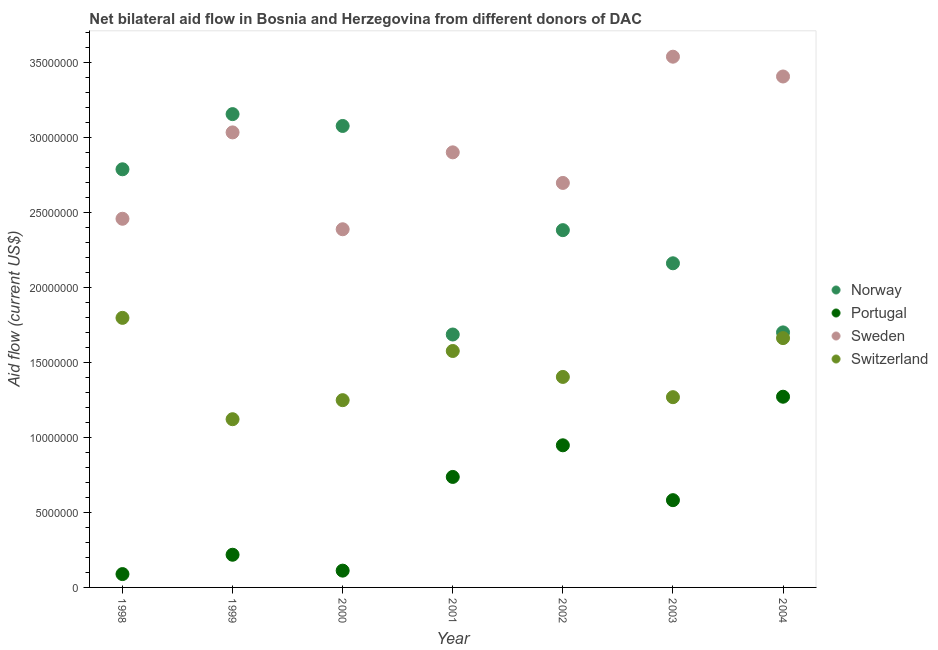How many different coloured dotlines are there?
Make the answer very short. 4. Is the number of dotlines equal to the number of legend labels?
Your response must be concise. Yes. What is the amount of aid given by sweden in 2001?
Offer a terse response. 2.90e+07. Across all years, what is the maximum amount of aid given by switzerland?
Your answer should be very brief. 1.80e+07. Across all years, what is the minimum amount of aid given by sweden?
Offer a very short reply. 2.39e+07. In which year was the amount of aid given by sweden maximum?
Offer a terse response. 2003. What is the total amount of aid given by switzerland in the graph?
Your response must be concise. 1.01e+08. What is the difference between the amount of aid given by portugal in 1999 and that in 2004?
Give a very brief answer. -1.05e+07. What is the difference between the amount of aid given by sweden in 2001 and the amount of aid given by switzerland in 2000?
Offer a terse response. 1.65e+07. What is the average amount of aid given by switzerland per year?
Your response must be concise. 1.44e+07. In the year 2001, what is the difference between the amount of aid given by portugal and amount of aid given by sweden?
Your answer should be very brief. -2.16e+07. In how many years, is the amount of aid given by sweden greater than 28000000 US$?
Offer a very short reply. 4. What is the ratio of the amount of aid given by portugal in 2001 to that in 2003?
Ensure brevity in your answer.  1.27. What is the difference between the highest and the second highest amount of aid given by switzerland?
Offer a very short reply. 1.35e+06. What is the difference between the highest and the lowest amount of aid given by portugal?
Provide a succinct answer. 1.18e+07. Is the sum of the amount of aid given by switzerland in 2002 and 2004 greater than the maximum amount of aid given by portugal across all years?
Ensure brevity in your answer.  Yes. Is the amount of aid given by sweden strictly less than the amount of aid given by norway over the years?
Offer a very short reply. No. Are the values on the major ticks of Y-axis written in scientific E-notation?
Provide a succinct answer. No. Does the graph contain grids?
Make the answer very short. No. What is the title of the graph?
Provide a short and direct response. Net bilateral aid flow in Bosnia and Herzegovina from different donors of DAC. What is the label or title of the X-axis?
Ensure brevity in your answer.  Year. What is the Aid flow (current US$) in Norway in 1998?
Offer a terse response. 2.79e+07. What is the Aid flow (current US$) of Portugal in 1998?
Offer a terse response. 8.90e+05. What is the Aid flow (current US$) of Sweden in 1998?
Offer a very short reply. 2.46e+07. What is the Aid flow (current US$) in Switzerland in 1998?
Your response must be concise. 1.80e+07. What is the Aid flow (current US$) in Norway in 1999?
Keep it short and to the point. 3.16e+07. What is the Aid flow (current US$) in Portugal in 1999?
Give a very brief answer. 2.18e+06. What is the Aid flow (current US$) of Sweden in 1999?
Offer a terse response. 3.04e+07. What is the Aid flow (current US$) of Switzerland in 1999?
Your answer should be very brief. 1.12e+07. What is the Aid flow (current US$) in Norway in 2000?
Ensure brevity in your answer.  3.08e+07. What is the Aid flow (current US$) of Portugal in 2000?
Keep it short and to the point. 1.12e+06. What is the Aid flow (current US$) of Sweden in 2000?
Provide a short and direct response. 2.39e+07. What is the Aid flow (current US$) in Switzerland in 2000?
Your response must be concise. 1.25e+07. What is the Aid flow (current US$) of Norway in 2001?
Make the answer very short. 1.69e+07. What is the Aid flow (current US$) of Portugal in 2001?
Provide a succinct answer. 7.37e+06. What is the Aid flow (current US$) of Sweden in 2001?
Give a very brief answer. 2.90e+07. What is the Aid flow (current US$) in Switzerland in 2001?
Your response must be concise. 1.58e+07. What is the Aid flow (current US$) in Norway in 2002?
Provide a short and direct response. 2.38e+07. What is the Aid flow (current US$) of Portugal in 2002?
Give a very brief answer. 9.48e+06. What is the Aid flow (current US$) in Sweden in 2002?
Offer a very short reply. 2.70e+07. What is the Aid flow (current US$) in Switzerland in 2002?
Keep it short and to the point. 1.40e+07. What is the Aid flow (current US$) of Norway in 2003?
Offer a very short reply. 2.16e+07. What is the Aid flow (current US$) in Portugal in 2003?
Your answer should be very brief. 5.82e+06. What is the Aid flow (current US$) in Sweden in 2003?
Offer a very short reply. 3.54e+07. What is the Aid flow (current US$) in Switzerland in 2003?
Offer a terse response. 1.27e+07. What is the Aid flow (current US$) in Norway in 2004?
Your answer should be compact. 1.70e+07. What is the Aid flow (current US$) of Portugal in 2004?
Your response must be concise. 1.27e+07. What is the Aid flow (current US$) in Sweden in 2004?
Your response must be concise. 3.41e+07. What is the Aid flow (current US$) of Switzerland in 2004?
Your response must be concise. 1.66e+07. Across all years, what is the maximum Aid flow (current US$) in Norway?
Provide a short and direct response. 3.16e+07. Across all years, what is the maximum Aid flow (current US$) in Portugal?
Your answer should be compact. 1.27e+07. Across all years, what is the maximum Aid flow (current US$) of Sweden?
Provide a short and direct response. 3.54e+07. Across all years, what is the maximum Aid flow (current US$) of Switzerland?
Give a very brief answer. 1.80e+07. Across all years, what is the minimum Aid flow (current US$) in Norway?
Your answer should be compact. 1.69e+07. Across all years, what is the minimum Aid flow (current US$) in Portugal?
Give a very brief answer. 8.90e+05. Across all years, what is the minimum Aid flow (current US$) in Sweden?
Keep it short and to the point. 2.39e+07. Across all years, what is the minimum Aid flow (current US$) in Switzerland?
Provide a succinct answer. 1.12e+07. What is the total Aid flow (current US$) in Norway in the graph?
Offer a terse response. 1.70e+08. What is the total Aid flow (current US$) in Portugal in the graph?
Make the answer very short. 3.96e+07. What is the total Aid flow (current US$) in Sweden in the graph?
Ensure brevity in your answer.  2.04e+08. What is the total Aid flow (current US$) of Switzerland in the graph?
Offer a terse response. 1.01e+08. What is the difference between the Aid flow (current US$) of Norway in 1998 and that in 1999?
Your response must be concise. -3.68e+06. What is the difference between the Aid flow (current US$) of Portugal in 1998 and that in 1999?
Keep it short and to the point. -1.29e+06. What is the difference between the Aid flow (current US$) of Sweden in 1998 and that in 1999?
Make the answer very short. -5.76e+06. What is the difference between the Aid flow (current US$) of Switzerland in 1998 and that in 1999?
Keep it short and to the point. 6.76e+06. What is the difference between the Aid flow (current US$) of Norway in 1998 and that in 2000?
Ensure brevity in your answer.  -2.89e+06. What is the difference between the Aid flow (current US$) in Sweden in 1998 and that in 2000?
Provide a succinct answer. 7.00e+05. What is the difference between the Aid flow (current US$) in Switzerland in 1998 and that in 2000?
Offer a terse response. 5.49e+06. What is the difference between the Aid flow (current US$) in Norway in 1998 and that in 2001?
Offer a terse response. 1.10e+07. What is the difference between the Aid flow (current US$) in Portugal in 1998 and that in 2001?
Your answer should be compact. -6.48e+06. What is the difference between the Aid flow (current US$) of Sweden in 1998 and that in 2001?
Provide a succinct answer. -4.43e+06. What is the difference between the Aid flow (current US$) in Switzerland in 1998 and that in 2001?
Give a very brief answer. 2.21e+06. What is the difference between the Aid flow (current US$) of Norway in 1998 and that in 2002?
Provide a succinct answer. 4.06e+06. What is the difference between the Aid flow (current US$) of Portugal in 1998 and that in 2002?
Keep it short and to the point. -8.59e+06. What is the difference between the Aid flow (current US$) of Sweden in 1998 and that in 2002?
Offer a terse response. -2.39e+06. What is the difference between the Aid flow (current US$) in Switzerland in 1998 and that in 2002?
Your response must be concise. 3.94e+06. What is the difference between the Aid flow (current US$) of Norway in 1998 and that in 2003?
Provide a short and direct response. 6.27e+06. What is the difference between the Aid flow (current US$) of Portugal in 1998 and that in 2003?
Your answer should be compact. -4.93e+06. What is the difference between the Aid flow (current US$) in Sweden in 1998 and that in 2003?
Your response must be concise. -1.08e+07. What is the difference between the Aid flow (current US$) of Switzerland in 1998 and that in 2003?
Your answer should be very brief. 5.29e+06. What is the difference between the Aid flow (current US$) in Norway in 1998 and that in 2004?
Your answer should be very brief. 1.09e+07. What is the difference between the Aid flow (current US$) of Portugal in 1998 and that in 2004?
Make the answer very short. -1.18e+07. What is the difference between the Aid flow (current US$) in Sweden in 1998 and that in 2004?
Ensure brevity in your answer.  -9.49e+06. What is the difference between the Aid flow (current US$) of Switzerland in 1998 and that in 2004?
Offer a very short reply. 1.35e+06. What is the difference between the Aid flow (current US$) of Norway in 1999 and that in 2000?
Ensure brevity in your answer.  7.90e+05. What is the difference between the Aid flow (current US$) of Portugal in 1999 and that in 2000?
Give a very brief answer. 1.06e+06. What is the difference between the Aid flow (current US$) of Sweden in 1999 and that in 2000?
Ensure brevity in your answer.  6.46e+06. What is the difference between the Aid flow (current US$) of Switzerland in 1999 and that in 2000?
Give a very brief answer. -1.27e+06. What is the difference between the Aid flow (current US$) of Norway in 1999 and that in 2001?
Make the answer very short. 1.47e+07. What is the difference between the Aid flow (current US$) of Portugal in 1999 and that in 2001?
Give a very brief answer. -5.19e+06. What is the difference between the Aid flow (current US$) of Sweden in 1999 and that in 2001?
Give a very brief answer. 1.33e+06. What is the difference between the Aid flow (current US$) of Switzerland in 1999 and that in 2001?
Provide a short and direct response. -4.55e+06. What is the difference between the Aid flow (current US$) in Norway in 1999 and that in 2002?
Your answer should be compact. 7.74e+06. What is the difference between the Aid flow (current US$) in Portugal in 1999 and that in 2002?
Make the answer very short. -7.30e+06. What is the difference between the Aid flow (current US$) of Sweden in 1999 and that in 2002?
Make the answer very short. 3.37e+06. What is the difference between the Aid flow (current US$) of Switzerland in 1999 and that in 2002?
Make the answer very short. -2.82e+06. What is the difference between the Aid flow (current US$) of Norway in 1999 and that in 2003?
Your answer should be compact. 9.95e+06. What is the difference between the Aid flow (current US$) in Portugal in 1999 and that in 2003?
Offer a very short reply. -3.64e+06. What is the difference between the Aid flow (current US$) of Sweden in 1999 and that in 2003?
Provide a short and direct response. -5.05e+06. What is the difference between the Aid flow (current US$) of Switzerland in 1999 and that in 2003?
Make the answer very short. -1.47e+06. What is the difference between the Aid flow (current US$) of Norway in 1999 and that in 2004?
Keep it short and to the point. 1.46e+07. What is the difference between the Aid flow (current US$) of Portugal in 1999 and that in 2004?
Offer a very short reply. -1.05e+07. What is the difference between the Aid flow (current US$) in Sweden in 1999 and that in 2004?
Ensure brevity in your answer.  -3.73e+06. What is the difference between the Aid flow (current US$) of Switzerland in 1999 and that in 2004?
Keep it short and to the point. -5.41e+06. What is the difference between the Aid flow (current US$) of Norway in 2000 and that in 2001?
Make the answer very short. 1.39e+07. What is the difference between the Aid flow (current US$) in Portugal in 2000 and that in 2001?
Your answer should be compact. -6.25e+06. What is the difference between the Aid flow (current US$) of Sweden in 2000 and that in 2001?
Provide a short and direct response. -5.13e+06. What is the difference between the Aid flow (current US$) of Switzerland in 2000 and that in 2001?
Your answer should be very brief. -3.28e+06. What is the difference between the Aid flow (current US$) in Norway in 2000 and that in 2002?
Your answer should be very brief. 6.95e+06. What is the difference between the Aid flow (current US$) of Portugal in 2000 and that in 2002?
Offer a very short reply. -8.36e+06. What is the difference between the Aid flow (current US$) of Sweden in 2000 and that in 2002?
Ensure brevity in your answer.  -3.09e+06. What is the difference between the Aid flow (current US$) in Switzerland in 2000 and that in 2002?
Make the answer very short. -1.55e+06. What is the difference between the Aid flow (current US$) of Norway in 2000 and that in 2003?
Give a very brief answer. 9.16e+06. What is the difference between the Aid flow (current US$) in Portugal in 2000 and that in 2003?
Provide a succinct answer. -4.70e+06. What is the difference between the Aid flow (current US$) of Sweden in 2000 and that in 2003?
Provide a succinct answer. -1.15e+07. What is the difference between the Aid flow (current US$) in Norway in 2000 and that in 2004?
Your answer should be compact. 1.38e+07. What is the difference between the Aid flow (current US$) of Portugal in 2000 and that in 2004?
Provide a succinct answer. -1.16e+07. What is the difference between the Aid flow (current US$) in Sweden in 2000 and that in 2004?
Your answer should be compact. -1.02e+07. What is the difference between the Aid flow (current US$) in Switzerland in 2000 and that in 2004?
Give a very brief answer. -4.14e+06. What is the difference between the Aid flow (current US$) of Norway in 2001 and that in 2002?
Your answer should be very brief. -6.96e+06. What is the difference between the Aid flow (current US$) in Portugal in 2001 and that in 2002?
Ensure brevity in your answer.  -2.11e+06. What is the difference between the Aid flow (current US$) of Sweden in 2001 and that in 2002?
Provide a short and direct response. 2.04e+06. What is the difference between the Aid flow (current US$) of Switzerland in 2001 and that in 2002?
Make the answer very short. 1.73e+06. What is the difference between the Aid flow (current US$) in Norway in 2001 and that in 2003?
Ensure brevity in your answer.  -4.75e+06. What is the difference between the Aid flow (current US$) of Portugal in 2001 and that in 2003?
Offer a terse response. 1.55e+06. What is the difference between the Aid flow (current US$) of Sweden in 2001 and that in 2003?
Your answer should be compact. -6.38e+06. What is the difference between the Aid flow (current US$) of Switzerland in 2001 and that in 2003?
Make the answer very short. 3.08e+06. What is the difference between the Aid flow (current US$) of Norway in 2001 and that in 2004?
Ensure brevity in your answer.  -1.40e+05. What is the difference between the Aid flow (current US$) of Portugal in 2001 and that in 2004?
Offer a terse response. -5.35e+06. What is the difference between the Aid flow (current US$) of Sweden in 2001 and that in 2004?
Your answer should be compact. -5.06e+06. What is the difference between the Aid flow (current US$) of Switzerland in 2001 and that in 2004?
Give a very brief answer. -8.60e+05. What is the difference between the Aid flow (current US$) of Norway in 2002 and that in 2003?
Keep it short and to the point. 2.21e+06. What is the difference between the Aid flow (current US$) of Portugal in 2002 and that in 2003?
Offer a very short reply. 3.66e+06. What is the difference between the Aid flow (current US$) in Sweden in 2002 and that in 2003?
Your answer should be compact. -8.42e+06. What is the difference between the Aid flow (current US$) of Switzerland in 2002 and that in 2003?
Your response must be concise. 1.35e+06. What is the difference between the Aid flow (current US$) in Norway in 2002 and that in 2004?
Give a very brief answer. 6.82e+06. What is the difference between the Aid flow (current US$) of Portugal in 2002 and that in 2004?
Your response must be concise. -3.24e+06. What is the difference between the Aid flow (current US$) of Sweden in 2002 and that in 2004?
Offer a terse response. -7.10e+06. What is the difference between the Aid flow (current US$) of Switzerland in 2002 and that in 2004?
Offer a terse response. -2.59e+06. What is the difference between the Aid flow (current US$) in Norway in 2003 and that in 2004?
Provide a short and direct response. 4.61e+06. What is the difference between the Aid flow (current US$) of Portugal in 2003 and that in 2004?
Provide a succinct answer. -6.90e+06. What is the difference between the Aid flow (current US$) of Sweden in 2003 and that in 2004?
Give a very brief answer. 1.32e+06. What is the difference between the Aid flow (current US$) in Switzerland in 2003 and that in 2004?
Offer a very short reply. -3.94e+06. What is the difference between the Aid flow (current US$) in Norway in 1998 and the Aid flow (current US$) in Portugal in 1999?
Make the answer very short. 2.57e+07. What is the difference between the Aid flow (current US$) in Norway in 1998 and the Aid flow (current US$) in Sweden in 1999?
Your answer should be very brief. -2.46e+06. What is the difference between the Aid flow (current US$) in Norway in 1998 and the Aid flow (current US$) in Switzerland in 1999?
Ensure brevity in your answer.  1.67e+07. What is the difference between the Aid flow (current US$) in Portugal in 1998 and the Aid flow (current US$) in Sweden in 1999?
Make the answer very short. -2.95e+07. What is the difference between the Aid flow (current US$) in Portugal in 1998 and the Aid flow (current US$) in Switzerland in 1999?
Provide a short and direct response. -1.03e+07. What is the difference between the Aid flow (current US$) in Sweden in 1998 and the Aid flow (current US$) in Switzerland in 1999?
Give a very brief answer. 1.34e+07. What is the difference between the Aid flow (current US$) of Norway in 1998 and the Aid flow (current US$) of Portugal in 2000?
Your answer should be compact. 2.68e+07. What is the difference between the Aid flow (current US$) of Norway in 1998 and the Aid flow (current US$) of Switzerland in 2000?
Keep it short and to the point. 1.54e+07. What is the difference between the Aid flow (current US$) in Portugal in 1998 and the Aid flow (current US$) in Sweden in 2000?
Provide a succinct answer. -2.30e+07. What is the difference between the Aid flow (current US$) in Portugal in 1998 and the Aid flow (current US$) in Switzerland in 2000?
Your answer should be compact. -1.16e+07. What is the difference between the Aid flow (current US$) in Sweden in 1998 and the Aid flow (current US$) in Switzerland in 2000?
Provide a short and direct response. 1.21e+07. What is the difference between the Aid flow (current US$) in Norway in 1998 and the Aid flow (current US$) in Portugal in 2001?
Give a very brief answer. 2.05e+07. What is the difference between the Aid flow (current US$) of Norway in 1998 and the Aid flow (current US$) of Sweden in 2001?
Provide a succinct answer. -1.13e+06. What is the difference between the Aid flow (current US$) in Norway in 1998 and the Aid flow (current US$) in Switzerland in 2001?
Keep it short and to the point. 1.21e+07. What is the difference between the Aid flow (current US$) of Portugal in 1998 and the Aid flow (current US$) of Sweden in 2001?
Offer a terse response. -2.81e+07. What is the difference between the Aid flow (current US$) of Portugal in 1998 and the Aid flow (current US$) of Switzerland in 2001?
Ensure brevity in your answer.  -1.49e+07. What is the difference between the Aid flow (current US$) of Sweden in 1998 and the Aid flow (current US$) of Switzerland in 2001?
Your answer should be compact. 8.82e+06. What is the difference between the Aid flow (current US$) in Norway in 1998 and the Aid flow (current US$) in Portugal in 2002?
Keep it short and to the point. 1.84e+07. What is the difference between the Aid flow (current US$) of Norway in 1998 and the Aid flow (current US$) of Sweden in 2002?
Your answer should be compact. 9.10e+05. What is the difference between the Aid flow (current US$) of Norway in 1998 and the Aid flow (current US$) of Switzerland in 2002?
Provide a short and direct response. 1.38e+07. What is the difference between the Aid flow (current US$) of Portugal in 1998 and the Aid flow (current US$) of Sweden in 2002?
Your response must be concise. -2.61e+07. What is the difference between the Aid flow (current US$) of Portugal in 1998 and the Aid flow (current US$) of Switzerland in 2002?
Provide a succinct answer. -1.32e+07. What is the difference between the Aid flow (current US$) in Sweden in 1998 and the Aid flow (current US$) in Switzerland in 2002?
Keep it short and to the point. 1.06e+07. What is the difference between the Aid flow (current US$) in Norway in 1998 and the Aid flow (current US$) in Portugal in 2003?
Your answer should be compact. 2.21e+07. What is the difference between the Aid flow (current US$) of Norway in 1998 and the Aid flow (current US$) of Sweden in 2003?
Give a very brief answer. -7.51e+06. What is the difference between the Aid flow (current US$) in Norway in 1998 and the Aid flow (current US$) in Switzerland in 2003?
Give a very brief answer. 1.52e+07. What is the difference between the Aid flow (current US$) in Portugal in 1998 and the Aid flow (current US$) in Sweden in 2003?
Offer a terse response. -3.45e+07. What is the difference between the Aid flow (current US$) of Portugal in 1998 and the Aid flow (current US$) of Switzerland in 2003?
Offer a terse response. -1.18e+07. What is the difference between the Aid flow (current US$) in Sweden in 1998 and the Aid flow (current US$) in Switzerland in 2003?
Your response must be concise. 1.19e+07. What is the difference between the Aid flow (current US$) of Norway in 1998 and the Aid flow (current US$) of Portugal in 2004?
Your answer should be compact. 1.52e+07. What is the difference between the Aid flow (current US$) in Norway in 1998 and the Aid flow (current US$) in Sweden in 2004?
Your answer should be very brief. -6.19e+06. What is the difference between the Aid flow (current US$) of Norway in 1998 and the Aid flow (current US$) of Switzerland in 2004?
Provide a succinct answer. 1.13e+07. What is the difference between the Aid flow (current US$) of Portugal in 1998 and the Aid flow (current US$) of Sweden in 2004?
Provide a short and direct response. -3.32e+07. What is the difference between the Aid flow (current US$) in Portugal in 1998 and the Aid flow (current US$) in Switzerland in 2004?
Your answer should be very brief. -1.57e+07. What is the difference between the Aid flow (current US$) in Sweden in 1998 and the Aid flow (current US$) in Switzerland in 2004?
Provide a succinct answer. 7.96e+06. What is the difference between the Aid flow (current US$) of Norway in 1999 and the Aid flow (current US$) of Portugal in 2000?
Provide a short and direct response. 3.04e+07. What is the difference between the Aid flow (current US$) in Norway in 1999 and the Aid flow (current US$) in Sweden in 2000?
Give a very brief answer. 7.68e+06. What is the difference between the Aid flow (current US$) of Norway in 1999 and the Aid flow (current US$) of Switzerland in 2000?
Provide a short and direct response. 1.91e+07. What is the difference between the Aid flow (current US$) of Portugal in 1999 and the Aid flow (current US$) of Sweden in 2000?
Provide a short and direct response. -2.17e+07. What is the difference between the Aid flow (current US$) of Portugal in 1999 and the Aid flow (current US$) of Switzerland in 2000?
Give a very brief answer. -1.03e+07. What is the difference between the Aid flow (current US$) in Sweden in 1999 and the Aid flow (current US$) in Switzerland in 2000?
Keep it short and to the point. 1.79e+07. What is the difference between the Aid flow (current US$) in Norway in 1999 and the Aid flow (current US$) in Portugal in 2001?
Provide a short and direct response. 2.42e+07. What is the difference between the Aid flow (current US$) in Norway in 1999 and the Aid flow (current US$) in Sweden in 2001?
Your answer should be compact. 2.55e+06. What is the difference between the Aid flow (current US$) in Norway in 1999 and the Aid flow (current US$) in Switzerland in 2001?
Make the answer very short. 1.58e+07. What is the difference between the Aid flow (current US$) in Portugal in 1999 and the Aid flow (current US$) in Sweden in 2001?
Your answer should be very brief. -2.68e+07. What is the difference between the Aid flow (current US$) of Portugal in 1999 and the Aid flow (current US$) of Switzerland in 2001?
Offer a very short reply. -1.36e+07. What is the difference between the Aid flow (current US$) in Sweden in 1999 and the Aid flow (current US$) in Switzerland in 2001?
Your response must be concise. 1.46e+07. What is the difference between the Aid flow (current US$) of Norway in 1999 and the Aid flow (current US$) of Portugal in 2002?
Your response must be concise. 2.21e+07. What is the difference between the Aid flow (current US$) in Norway in 1999 and the Aid flow (current US$) in Sweden in 2002?
Your answer should be compact. 4.59e+06. What is the difference between the Aid flow (current US$) of Norway in 1999 and the Aid flow (current US$) of Switzerland in 2002?
Offer a very short reply. 1.75e+07. What is the difference between the Aid flow (current US$) in Portugal in 1999 and the Aid flow (current US$) in Sweden in 2002?
Your response must be concise. -2.48e+07. What is the difference between the Aid flow (current US$) in Portugal in 1999 and the Aid flow (current US$) in Switzerland in 2002?
Ensure brevity in your answer.  -1.19e+07. What is the difference between the Aid flow (current US$) of Sweden in 1999 and the Aid flow (current US$) of Switzerland in 2002?
Provide a short and direct response. 1.63e+07. What is the difference between the Aid flow (current US$) in Norway in 1999 and the Aid flow (current US$) in Portugal in 2003?
Give a very brief answer. 2.58e+07. What is the difference between the Aid flow (current US$) of Norway in 1999 and the Aid flow (current US$) of Sweden in 2003?
Keep it short and to the point. -3.83e+06. What is the difference between the Aid flow (current US$) in Norway in 1999 and the Aid flow (current US$) in Switzerland in 2003?
Your answer should be compact. 1.89e+07. What is the difference between the Aid flow (current US$) of Portugal in 1999 and the Aid flow (current US$) of Sweden in 2003?
Provide a short and direct response. -3.32e+07. What is the difference between the Aid flow (current US$) in Portugal in 1999 and the Aid flow (current US$) in Switzerland in 2003?
Ensure brevity in your answer.  -1.05e+07. What is the difference between the Aid flow (current US$) of Sweden in 1999 and the Aid flow (current US$) of Switzerland in 2003?
Ensure brevity in your answer.  1.77e+07. What is the difference between the Aid flow (current US$) of Norway in 1999 and the Aid flow (current US$) of Portugal in 2004?
Ensure brevity in your answer.  1.88e+07. What is the difference between the Aid flow (current US$) of Norway in 1999 and the Aid flow (current US$) of Sweden in 2004?
Offer a very short reply. -2.51e+06. What is the difference between the Aid flow (current US$) of Norway in 1999 and the Aid flow (current US$) of Switzerland in 2004?
Provide a succinct answer. 1.49e+07. What is the difference between the Aid flow (current US$) in Portugal in 1999 and the Aid flow (current US$) in Sweden in 2004?
Offer a terse response. -3.19e+07. What is the difference between the Aid flow (current US$) of Portugal in 1999 and the Aid flow (current US$) of Switzerland in 2004?
Your answer should be very brief. -1.44e+07. What is the difference between the Aid flow (current US$) of Sweden in 1999 and the Aid flow (current US$) of Switzerland in 2004?
Offer a terse response. 1.37e+07. What is the difference between the Aid flow (current US$) in Norway in 2000 and the Aid flow (current US$) in Portugal in 2001?
Your response must be concise. 2.34e+07. What is the difference between the Aid flow (current US$) of Norway in 2000 and the Aid flow (current US$) of Sweden in 2001?
Keep it short and to the point. 1.76e+06. What is the difference between the Aid flow (current US$) in Norway in 2000 and the Aid flow (current US$) in Switzerland in 2001?
Offer a very short reply. 1.50e+07. What is the difference between the Aid flow (current US$) of Portugal in 2000 and the Aid flow (current US$) of Sweden in 2001?
Your answer should be very brief. -2.79e+07. What is the difference between the Aid flow (current US$) of Portugal in 2000 and the Aid flow (current US$) of Switzerland in 2001?
Offer a terse response. -1.46e+07. What is the difference between the Aid flow (current US$) in Sweden in 2000 and the Aid flow (current US$) in Switzerland in 2001?
Provide a succinct answer. 8.12e+06. What is the difference between the Aid flow (current US$) in Norway in 2000 and the Aid flow (current US$) in Portugal in 2002?
Your answer should be compact. 2.13e+07. What is the difference between the Aid flow (current US$) in Norway in 2000 and the Aid flow (current US$) in Sweden in 2002?
Make the answer very short. 3.80e+06. What is the difference between the Aid flow (current US$) in Norway in 2000 and the Aid flow (current US$) in Switzerland in 2002?
Keep it short and to the point. 1.67e+07. What is the difference between the Aid flow (current US$) in Portugal in 2000 and the Aid flow (current US$) in Sweden in 2002?
Offer a terse response. -2.59e+07. What is the difference between the Aid flow (current US$) in Portugal in 2000 and the Aid flow (current US$) in Switzerland in 2002?
Your answer should be compact. -1.29e+07. What is the difference between the Aid flow (current US$) of Sweden in 2000 and the Aid flow (current US$) of Switzerland in 2002?
Give a very brief answer. 9.85e+06. What is the difference between the Aid flow (current US$) in Norway in 2000 and the Aid flow (current US$) in Portugal in 2003?
Your answer should be compact. 2.50e+07. What is the difference between the Aid flow (current US$) in Norway in 2000 and the Aid flow (current US$) in Sweden in 2003?
Your answer should be compact. -4.62e+06. What is the difference between the Aid flow (current US$) of Norway in 2000 and the Aid flow (current US$) of Switzerland in 2003?
Give a very brief answer. 1.81e+07. What is the difference between the Aid flow (current US$) of Portugal in 2000 and the Aid flow (current US$) of Sweden in 2003?
Give a very brief answer. -3.43e+07. What is the difference between the Aid flow (current US$) in Portugal in 2000 and the Aid flow (current US$) in Switzerland in 2003?
Your answer should be very brief. -1.16e+07. What is the difference between the Aid flow (current US$) of Sweden in 2000 and the Aid flow (current US$) of Switzerland in 2003?
Make the answer very short. 1.12e+07. What is the difference between the Aid flow (current US$) of Norway in 2000 and the Aid flow (current US$) of Portugal in 2004?
Provide a short and direct response. 1.81e+07. What is the difference between the Aid flow (current US$) in Norway in 2000 and the Aid flow (current US$) in Sweden in 2004?
Offer a very short reply. -3.30e+06. What is the difference between the Aid flow (current US$) of Norway in 2000 and the Aid flow (current US$) of Switzerland in 2004?
Your answer should be very brief. 1.42e+07. What is the difference between the Aid flow (current US$) in Portugal in 2000 and the Aid flow (current US$) in Sweden in 2004?
Offer a very short reply. -3.30e+07. What is the difference between the Aid flow (current US$) of Portugal in 2000 and the Aid flow (current US$) of Switzerland in 2004?
Offer a very short reply. -1.55e+07. What is the difference between the Aid flow (current US$) of Sweden in 2000 and the Aid flow (current US$) of Switzerland in 2004?
Ensure brevity in your answer.  7.26e+06. What is the difference between the Aid flow (current US$) of Norway in 2001 and the Aid flow (current US$) of Portugal in 2002?
Ensure brevity in your answer.  7.39e+06. What is the difference between the Aid flow (current US$) in Norway in 2001 and the Aid flow (current US$) in Sweden in 2002?
Your answer should be very brief. -1.01e+07. What is the difference between the Aid flow (current US$) in Norway in 2001 and the Aid flow (current US$) in Switzerland in 2002?
Your response must be concise. 2.83e+06. What is the difference between the Aid flow (current US$) of Portugal in 2001 and the Aid flow (current US$) of Sweden in 2002?
Provide a succinct answer. -1.96e+07. What is the difference between the Aid flow (current US$) of Portugal in 2001 and the Aid flow (current US$) of Switzerland in 2002?
Give a very brief answer. -6.67e+06. What is the difference between the Aid flow (current US$) in Sweden in 2001 and the Aid flow (current US$) in Switzerland in 2002?
Offer a terse response. 1.50e+07. What is the difference between the Aid flow (current US$) in Norway in 2001 and the Aid flow (current US$) in Portugal in 2003?
Offer a terse response. 1.10e+07. What is the difference between the Aid flow (current US$) of Norway in 2001 and the Aid flow (current US$) of Sweden in 2003?
Your answer should be compact. -1.85e+07. What is the difference between the Aid flow (current US$) in Norway in 2001 and the Aid flow (current US$) in Switzerland in 2003?
Your response must be concise. 4.18e+06. What is the difference between the Aid flow (current US$) in Portugal in 2001 and the Aid flow (current US$) in Sweden in 2003?
Ensure brevity in your answer.  -2.80e+07. What is the difference between the Aid flow (current US$) in Portugal in 2001 and the Aid flow (current US$) in Switzerland in 2003?
Provide a short and direct response. -5.32e+06. What is the difference between the Aid flow (current US$) in Sweden in 2001 and the Aid flow (current US$) in Switzerland in 2003?
Keep it short and to the point. 1.63e+07. What is the difference between the Aid flow (current US$) in Norway in 2001 and the Aid flow (current US$) in Portugal in 2004?
Offer a very short reply. 4.15e+06. What is the difference between the Aid flow (current US$) in Norway in 2001 and the Aid flow (current US$) in Sweden in 2004?
Your response must be concise. -1.72e+07. What is the difference between the Aid flow (current US$) of Norway in 2001 and the Aid flow (current US$) of Switzerland in 2004?
Give a very brief answer. 2.40e+05. What is the difference between the Aid flow (current US$) of Portugal in 2001 and the Aid flow (current US$) of Sweden in 2004?
Provide a short and direct response. -2.67e+07. What is the difference between the Aid flow (current US$) in Portugal in 2001 and the Aid flow (current US$) in Switzerland in 2004?
Keep it short and to the point. -9.26e+06. What is the difference between the Aid flow (current US$) in Sweden in 2001 and the Aid flow (current US$) in Switzerland in 2004?
Provide a succinct answer. 1.24e+07. What is the difference between the Aid flow (current US$) of Norway in 2002 and the Aid flow (current US$) of Portugal in 2003?
Keep it short and to the point. 1.80e+07. What is the difference between the Aid flow (current US$) in Norway in 2002 and the Aid flow (current US$) in Sweden in 2003?
Offer a terse response. -1.16e+07. What is the difference between the Aid flow (current US$) of Norway in 2002 and the Aid flow (current US$) of Switzerland in 2003?
Provide a short and direct response. 1.11e+07. What is the difference between the Aid flow (current US$) in Portugal in 2002 and the Aid flow (current US$) in Sweden in 2003?
Give a very brief answer. -2.59e+07. What is the difference between the Aid flow (current US$) in Portugal in 2002 and the Aid flow (current US$) in Switzerland in 2003?
Give a very brief answer. -3.21e+06. What is the difference between the Aid flow (current US$) of Sweden in 2002 and the Aid flow (current US$) of Switzerland in 2003?
Give a very brief answer. 1.43e+07. What is the difference between the Aid flow (current US$) of Norway in 2002 and the Aid flow (current US$) of Portugal in 2004?
Make the answer very short. 1.11e+07. What is the difference between the Aid flow (current US$) of Norway in 2002 and the Aid flow (current US$) of Sweden in 2004?
Ensure brevity in your answer.  -1.02e+07. What is the difference between the Aid flow (current US$) of Norway in 2002 and the Aid flow (current US$) of Switzerland in 2004?
Your answer should be compact. 7.20e+06. What is the difference between the Aid flow (current US$) of Portugal in 2002 and the Aid flow (current US$) of Sweden in 2004?
Offer a terse response. -2.46e+07. What is the difference between the Aid flow (current US$) in Portugal in 2002 and the Aid flow (current US$) in Switzerland in 2004?
Ensure brevity in your answer.  -7.15e+06. What is the difference between the Aid flow (current US$) in Sweden in 2002 and the Aid flow (current US$) in Switzerland in 2004?
Offer a terse response. 1.04e+07. What is the difference between the Aid flow (current US$) of Norway in 2003 and the Aid flow (current US$) of Portugal in 2004?
Offer a terse response. 8.90e+06. What is the difference between the Aid flow (current US$) of Norway in 2003 and the Aid flow (current US$) of Sweden in 2004?
Your answer should be compact. -1.25e+07. What is the difference between the Aid flow (current US$) in Norway in 2003 and the Aid flow (current US$) in Switzerland in 2004?
Your answer should be compact. 4.99e+06. What is the difference between the Aid flow (current US$) of Portugal in 2003 and the Aid flow (current US$) of Sweden in 2004?
Keep it short and to the point. -2.83e+07. What is the difference between the Aid flow (current US$) of Portugal in 2003 and the Aid flow (current US$) of Switzerland in 2004?
Provide a succinct answer. -1.08e+07. What is the difference between the Aid flow (current US$) in Sweden in 2003 and the Aid flow (current US$) in Switzerland in 2004?
Your answer should be very brief. 1.88e+07. What is the average Aid flow (current US$) of Norway per year?
Make the answer very short. 2.42e+07. What is the average Aid flow (current US$) in Portugal per year?
Your answer should be compact. 5.65e+06. What is the average Aid flow (current US$) in Sweden per year?
Provide a short and direct response. 2.92e+07. What is the average Aid flow (current US$) of Switzerland per year?
Your answer should be very brief. 1.44e+07. In the year 1998, what is the difference between the Aid flow (current US$) in Norway and Aid flow (current US$) in Portugal?
Keep it short and to the point. 2.70e+07. In the year 1998, what is the difference between the Aid flow (current US$) in Norway and Aid flow (current US$) in Sweden?
Offer a terse response. 3.30e+06. In the year 1998, what is the difference between the Aid flow (current US$) of Norway and Aid flow (current US$) of Switzerland?
Keep it short and to the point. 9.91e+06. In the year 1998, what is the difference between the Aid flow (current US$) in Portugal and Aid flow (current US$) in Sweden?
Give a very brief answer. -2.37e+07. In the year 1998, what is the difference between the Aid flow (current US$) of Portugal and Aid flow (current US$) of Switzerland?
Give a very brief answer. -1.71e+07. In the year 1998, what is the difference between the Aid flow (current US$) of Sweden and Aid flow (current US$) of Switzerland?
Keep it short and to the point. 6.61e+06. In the year 1999, what is the difference between the Aid flow (current US$) of Norway and Aid flow (current US$) of Portugal?
Offer a very short reply. 2.94e+07. In the year 1999, what is the difference between the Aid flow (current US$) of Norway and Aid flow (current US$) of Sweden?
Provide a short and direct response. 1.22e+06. In the year 1999, what is the difference between the Aid flow (current US$) in Norway and Aid flow (current US$) in Switzerland?
Your answer should be very brief. 2.04e+07. In the year 1999, what is the difference between the Aid flow (current US$) in Portugal and Aid flow (current US$) in Sweden?
Provide a succinct answer. -2.82e+07. In the year 1999, what is the difference between the Aid flow (current US$) in Portugal and Aid flow (current US$) in Switzerland?
Give a very brief answer. -9.04e+06. In the year 1999, what is the difference between the Aid flow (current US$) of Sweden and Aid flow (current US$) of Switzerland?
Your response must be concise. 1.91e+07. In the year 2000, what is the difference between the Aid flow (current US$) of Norway and Aid flow (current US$) of Portugal?
Give a very brief answer. 2.97e+07. In the year 2000, what is the difference between the Aid flow (current US$) in Norway and Aid flow (current US$) in Sweden?
Keep it short and to the point. 6.89e+06. In the year 2000, what is the difference between the Aid flow (current US$) in Norway and Aid flow (current US$) in Switzerland?
Your response must be concise. 1.83e+07. In the year 2000, what is the difference between the Aid flow (current US$) of Portugal and Aid flow (current US$) of Sweden?
Your response must be concise. -2.28e+07. In the year 2000, what is the difference between the Aid flow (current US$) of Portugal and Aid flow (current US$) of Switzerland?
Provide a succinct answer. -1.14e+07. In the year 2000, what is the difference between the Aid flow (current US$) of Sweden and Aid flow (current US$) of Switzerland?
Provide a short and direct response. 1.14e+07. In the year 2001, what is the difference between the Aid flow (current US$) of Norway and Aid flow (current US$) of Portugal?
Make the answer very short. 9.50e+06. In the year 2001, what is the difference between the Aid flow (current US$) of Norway and Aid flow (current US$) of Sweden?
Your answer should be compact. -1.22e+07. In the year 2001, what is the difference between the Aid flow (current US$) of Norway and Aid flow (current US$) of Switzerland?
Ensure brevity in your answer.  1.10e+06. In the year 2001, what is the difference between the Aid flow (current US$) of Portugal and Aid flow (current US$) of Sweden?
Your response must be concise. -2.16e+07. In the year 2001, what is the difference between the Aid flow (current US$) in Portugal and Aid flow (current US$) in Switzerland?
Provide a succinct answer. -8.40e+06. In the year 2001, what is the difference between the Aid flow (current US$) in Sweden and Aid flow (current US$) in Switzerland?
Ensure brevity in your answer.  1.32e+07. In the year 2002, what is the difference between the Aid flow (current US$) in Norway and Aid flow (current US$) in Portugal?
Offer a very short reply. 1.44e+07. In the year 2002, what is the difference between the Aid flow (current US$) of Norway and Aid flow (current US$) of Sweden?
Make the answer very short. -3.15e+06. In the year 2002, what is the difference between the Aid flow (current US$) of Norway and Aid flow (current US$) of Switzerland?
Provide a succinct answer. 9.79e+06. In the year 2002, what is the difference between the Aid flow (current US$) in Portugal and Aid flow (current US$) in Sweden?
Your response must be concise. -1.75e+07. In the year 2002, what is the difference between the Aid flow (current US$) in Portugal and Aid flow (current US$) in Switzerland?
Ensure brevity in your answer.  -4.56e+06. In the year 2002, what is the difference between the Aid flow (current US$) in Sweden and Aid flow (current US$) in Switzerland?
Your answer should be compact. 1.29e+07. In the year 2003, what is the difference between the Aid flow (current US$) of Norway and Aid flow (current US$) of Portugal?
Give a very brief answer. 1.58e+07. In the year 2003, what is the difference between the Aid flow (current US$) in Norway and Aid flow (current US$) in Sweden?
Your answer should be very brief. -1.38e+07. In the year 2003, what is the difference between the Aid flow (current US$) in Norway and Aid flow (current US$) in Switzerland?
Ensure brevity in your answer.  8.93e+06. In the year 2003, what is the difference between the Aid flow (current US$) of Portugal and Aid flow (current US$) of Sweden?
Ensure brevity in your answer.  -2.96e+07. In the year 2003, what is the difference between the Aid flow (current US$) in Portugal and Aid flow (current US$) in Switzerland?
Offer a terse response. -6.87e+06. In the year 2003, what is the difference between the Aid flow (current US$) of Sweden and Aid flow (current US$) of Switzerland?
Provide a short and direct response. 2.27e+07. In the year 2004, what is the difference between the Aid flow (current US$) of Norway and Aid flow (current US$) of Portugal?
Offer a very short reply. 4.29e+06. In the year 2004, what is the difference between the Aid flow (current US$) of Norway and Aid flow (current US$) of Sweden?
Your answer should be compact. -1.71e+07. In the year 2004, what is the difference between the Aid flow (current US$) of Norway and Aid flow (current US$) of Switzerland?
Your answer should be compact. 3.80e+05. In the year 2004, what is the difference between the Aid flow (current US$) in Portugal and Aid flow (current US$) in Sweden?
Give a very brief answer. -2.14e+07. In the year 2004, what is the difference between the Aid flow (current US$) of Portugal and Aid flow (current US$) of Switzerland?
Your answer should be very brief. -3.91e+06. In the year 2004, what is the difference between the Aid flow (current US$) of Sweden and Aid flow (current US$) of Switzerland?
Your response must be concise. 1.74e+07. What is the ratio of the Aid flow (current US$) of Norway in 1998 to that in 1999?
Your answer should be very brief. 0.88. What is the ratio of the Aid flow (current US$) in Portugal in 1998 to that in 1999?
Keep it short and to the point. 0.41. What is the ratio of the Aid flow (current US$) of Sweden in 1998 to that in 1999?
Provide a short and direct response. 0.81. What is the ratio of the Aid flow (current US$) in Switzerland in 1998 to that in 1999?
Your answer should be very brief. 1.6. What is the ratio of the Aid flow (current US$) of Norway in 1998 to that in 2000?
Keep it short and to the point. 0.91. What is the ratio of the Aid flow (current US$) in Portugal in 1998 to that in 2000?
Provide a short and direct response. 0.79. What is the ratio of the Aid flow (current US$) of Sweden in 1998 to that in 2000?
Provide a succinct answer. 1.03. What is the ratio of the Aid flow (current US$) in Switzerland in 1998 to that in 2000?
Provide a succinct answer. 1.44. What is the ratio of the Aid flow (current US$) in Norway in 1998 to that in 2001?
Give a very brief answer. 1.65. What is the ratio of the Aid flow (current US$) of Portugal in 1998 to that in 2001?
Offer a very short reply. 0.12. What is the ratio of the Aid flow (current US$) of Sweden in 1998 to that in 2001?
Provide a short and direct response. 0.85. What is the ratio of the Aid flow (current US$) of Switzerland in 1998 to that in 2001?
Your response must be concise. 1.14. What is the ratio of the Aid flow (current US$) of Norway in 1998 to that in 2002?
Provide a succinct answer. 1.17. What is the ratio of the Aid flow (current US$) in Portugal in 1998 to that in 2002?
Provide a short and direct response. 0.09. What is the ratio of the Aid flow (current US$) of Sweden in 1998 to that in 2002?
Your answer should be very brief. 0.91. What is the ratio of the Aid flow (current US$) of Switzerland in 1998 to that in 2002?
Give a very brief answer. 1.28. What is the ratio of the Aid flow (current US$) in Norway in 1998 to that in 2003?
Provide a succinct answer. 1.29. What is the ratio of the Aid flow (current US$) in Portugal in 1998 to that in 2003?
Provide a succinct answer. 0.15. What is the ratio of the Aid flow (current US$) of Sweden in 1998 to that in 2003?
Your answer should be very brief. 0.69. What is the ratio of the Aid flow (current US$) in Switzerland in 1998 to that in 2003?
Keep it short and to the point. 1.42. What is the ratio of the Aid flow (current US$) of Norway in 1998 to that in 2004?
Give a very brief answer. 1.64. What is the ratio of the Aid flow (current US$) in Portugal in 1998 to that in 2004?
Give a very brief answer. 0.07. What is the ratio of the Aid flow (current US$) of Sweden in 1998 to that in 2004?
Ensure brevity in your answer.  0.72. What is the ratio of the Aid flow (current US$) in Switzerland in 1998 to that in 2004?
Offer a terse response. 1.08. What is the ratio of the Aid flow (current US$) in Norway in 1999 to that in 2000?
Offer a very short reply. 1.03. What is the ratio of the Aid flow (current US$) in Portugal in 1999 to that in 2000?
Your answer should be compact. 1.95. What is the ratio of the Aid flow (current US$) in Sweden in 1999 to that in 2000?
Your response must be concise. 1.27. What is the ratio of the Aid flow (current US$) of Switzerland in 1999 to that in 2000?
Give a very brief answer. 0.9. What is the ratio of the Aid flow (current US$) in Norway in 1999 to that in 2001?
Your answer should be compact. 1.87. What is the ratio of the Aid flow (current US$) in Portugal in 1999 to that in 2001?
Give a very brief answer. 0.3. What is the ratio of the Aid flow (current US$) of Sweden in 1999 to that in 2001?
Your answer should be compact. 1.05. What is the ratio of the Aid flow (current US$) of Switzerland in 1999 to that in 2001?
Ensure brevity in your answer.  0.71. What is the ratio of the Aid flow (current US$) of Norway in 1999 to that in 2002?
Provide a short and direct response. 1.32. What is the ratio of the Aid flow (current US$) of Portugal in 1999 to that in 2002?
Provide a short and direct response. 0.23. What is the ratio of the Aid flow (current US$) of Sweden in 1999 to that in 2002?
Offer a terse response. 1.12. What is the ratio of the Aid flow (current US$) in Switzerland in 1999 to that in 2002?
Offer a terse response. 0.8. What is the ratio of the Aid flow (current US$) of Norway in 1999 to that in 2003?
Offer a terse response. 1.46. What is the ratio of the Aid flow (current US$) in Portugal in 1999 to that in 2003?
Provide a succinct answer. 0.37. What is the ratio of the Aid flow (current US$) in Sweden in 1999 to that in 2003?
Ensure brevity in your answer.  0.86. What is the ratio of the Aid flow (current US$) of Switzerland in 1999 to that in 2003?
Keep it short and to the point. 0.88. What is the ratio of the Aid flow (current US$) of Norway in 1999 to that in 2004?
Provide a short and direct response. 1.86. What is the ratio of the Aid flow (current US$) in Portugal in 1999 to that in 2004?
Your answer should be very brief. 0.17. What is the ratio of the Aid flow (current US$) of Sweden in 1999 to that in 2004?
Your answer should be very brief. 0.89. What is the ratio of the Aid flow (current US$) in Switzerland in 1999 to that in 2004?
Keep it short and to the point. 0.67. What is the ratio of the Aid flow (current US$) of Norway in 2000 to that in 2001?
Offer a terse response. 1.82. What is the ratio of the Aid flow (current US$) of Portugal in 2000 to that in 2001?
Your answer should be very brief. 0.15. What is the ratio of the Aid flow (current US$) in Sweden in 2000 to that in 2001?
Your response must be concise. 0.82. What is the ratio of the Aid flow (current US$) in Switzerland in 2000 to that in 2001?
Make the answer very short. 0.79. What is the ratio of the Aid flow (current US$) in Norway in 2000 to that in 2002?
Offer a terse response. 1.29. What is the ratio of the Aid flow (current US$) of Portugal in 2000 to that in 2002?
Keep it short and to the point. 0.12. What is the ratio of the Aid flow (current US$) in Sweden in 2000 to that in 2002?
Offer a terse response. 0.89. What is the ratio of the Aid flow (current US$) in Switzerland in 2000 to that in 2002?
Offer a very short reply. 0.89. What is the ratio of the Aid flow (current US$) of Norway in 2000 to that in 2003?
Your response must be concise. 1.42. What is the ratio of the Aid flow (current US$) in Portugal in 2000 to that in 2003?
Offer a terse response. 0.19. What is the ratio of the Aid flow (current US$) of Sweden in 2000 to that in 2003?
Keep it short and to the point. 0.67. What is the ratio of the Aid flow (current US$) in Switzerland in 2000 to that in 2003?
Your answer should be very brief. 0.98. What is the ratio of the Aid flow (current US$) in Norway in 2000 to that in 2004?
Keep it short and to the point. 1.81. What is the ratio of the Aid flow (current US$) in Portugal in 2000 to that in 2004?
Make the answer very short. 0.09. What is the ratio of the Aid flow (current US$) in Sweden in 2000 to that in 2004?
Provide a succinct answer. 0.7. What is the ratio of the Aid flow (current US$) in Switzerland in 2000 to that in 2004?
Your response must be concise. 0.75. What is the ratio of the Aid flow (current US$) of Norway in 2001 to that in 2002?
Provide a succinct answer. 0.71. What is the ratio of the Aid flow (current US$) in Portugal in 2001 to that in 2002?
Give a very brief answer. 0.78. What is the ratio of the Aid flow (current US$) of Sweden in 2001 to that in 2002?
Make the answer very short. 1.08. What is the ratio of the Aid flow (current US$) of Switzerland in 2001 to that in 2002?
Your answer should be very brief. 1.12. What is the ratio of the Aid flow (current US$) of Norway in 2001 to that in 2003?
Provide a succinct answer. 0.78. What is the ratio of the Aid flow (current US$) in Portugal in 2001 to that in 2003?
Your answer should be compact. 1.27. What is the ratio of the Aid flow (current US$) in Sweden in 2001 to that in 2003?
Keep it short and to the point. 0.82. What is the ratio of the Aid flow (current US$) of Switzerland in 2001 to that in 2003?
Offer a very short reply. 1.24. What is the ratio of the Aid flow (current US$) of Portugal in 2001 to that in 2004?
Give a very brief answer. 0.58. What is the ratio of the Aid flow (current US$) in Sweden in 2001 to that in 2004?
Give a very brief answer. 0.85. What is the ratio of the Aid flow (current US$) of Switzerland in 2001 to that in 2004?
Provide a succinct answer. 0.95. What is the ratio of the Aid flow (current US$) of Norway in 2002 to that in 2003?
Make the answer very short. 1.1. What is the ratio of the Aid flow (current US$) of Portugal in 2002 to that in 2003?
Your response must be concise. 1.63. What is the ratio of the Aid flow (current US$) in Sweden in 2002 to that in 2003?
Provide a short and direct response. 0.76. What is the ratio of the Aid flow (current US$) in Switzerland in 2002 to that in 2003?
Keep it short and to the point. 1.11. What is the ratio of the Aid flow (current US$) in Norway in 2002 to that in 2004?
Your response must be concise. 1.4. What is the ratio of the Aid flow (current US$) of Portugal in 2002 to that in 2004?
Give a very brief answer. 0.75. What is the ratio of the Aid flow (current US$) of Sweden in 2002 to that in 2004?
Offer a terse response. 0.79. What is the ratio of the Aid flow (current US$) in Switzerland in 2002 to that in 2004?
Offer a very short reply. 0.84. What is the ratio of the Aid flow (current US$) of Norway in 2003 to that in 2004?
Make the answer very short. 1.27. What is the ratio of the Aid flow (current US$) of Portugal in 2003 to that in 2004?
Ensure brevity in your answer.  0.46. What is the ratio of the Aid flow (current US$) in Sweden in 2003 to that in 2004?
Give a very brief answer. 1.04. What is the ratio of the Aid flow (current US$) in Switzerland in 2003 to that in 2004?
Your response must be concise. 0.76. What is the difference between the highest and the second highest Aid flow (current US$) in Norway?
Offer a very short reply. 7.90e+05. What is the difference between the highest and the second highest Aid flow (current US$) of Portugal?
Offer a terse response. 3.24e+06. What is the difference between the highest and the second highest Aid flow (current US$) in Sweden?
Provide a short and direct response. 1.32e+06. What is the difference between the highest and the second highest Aid flow (current US$) of Switzerland?
Your answer should be very brief. 1.35e+06. What is the difference between the highest and the lowest Aid flow (current US$) of Norway?
Give a very brief answer. 1.47e+07. What is the difference between the highest and the lowest Aid flow (current US$) in Portugal?
Offer a terse response. 1.18e+07. What is the difference between the highest and the lowest Aid flow (current US$) of Sweden?
Provide a succinct answer. 1.15e+07. What is the difference between the highest and the lowest Aid flow (current US$) in Switzerland?
Make the answer very short. 6.76e+06. 